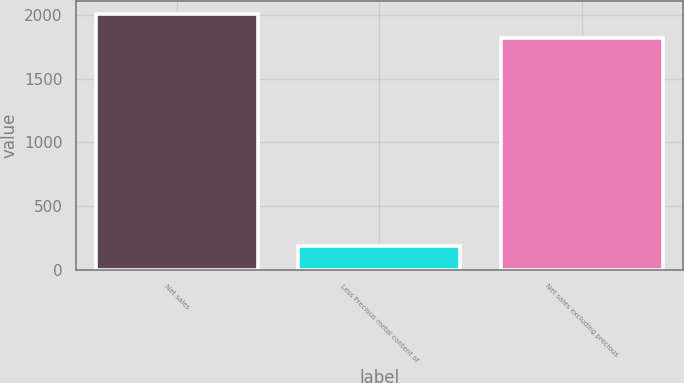<chart> <loc_0><loc_0><loc_500><loc_500><bar_chart><fcel>Net sales<fcel>Less Precious metal content of<fcel>Net sales excluding precious<nl><fcel>2009.8<fcel>189.9<fcel>1819.9<nl></chart> 